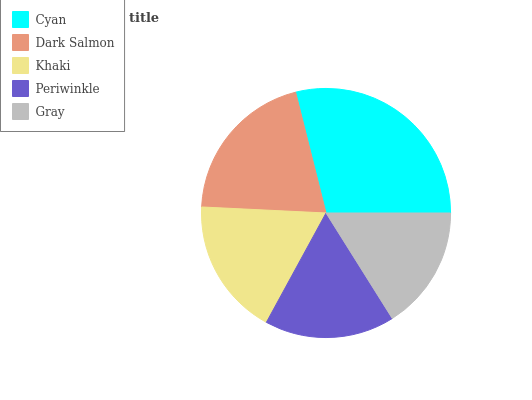Is Gray the minimum?
Answer yes or no. Yes. Is Cyan the maximum?
Answer yes or no. Yes. Is Dark Salmon the minimum?
Answer yes or no. No. Is Dark Salmon the maximum?
Answer yes or no. No. Is Cyan greater than Dark Salmon?
Answer yes or no. Yes. Is Dark Salmon less than Cyan?
Answer yes or no. Yes. Is Dark Salmon greater than Cyan?
Answer yes or no. No. Is Cyan less than Dark Salmon?
Answer yes or no. No. Is Khaki the high median?
Answer yes or no. Yes. Is Khaki the low median?
Answer yes or no. Yes. Is Gray the high median?
Answer yes or no. No. Is Periwinkle the low median?
Answer yes or no. No. 